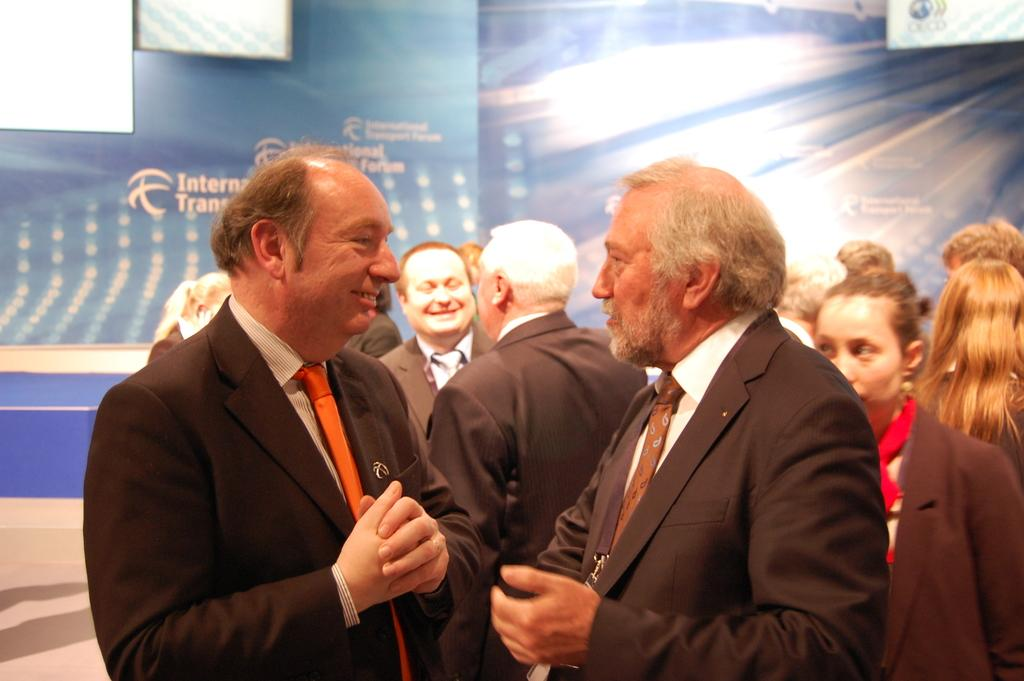What can be seen in the image? There is a group of people in the image. What are the people wearing? Most of the people are wearing suits. What can be seen in the background of the image? There is a different color sheet in the background of the image. Can you tell me how many chess pieces are on the table in the image? There is no table or chess pieces present in the image. What type of cup is being used by the person in the image? There is no cup or person visible in the image. 